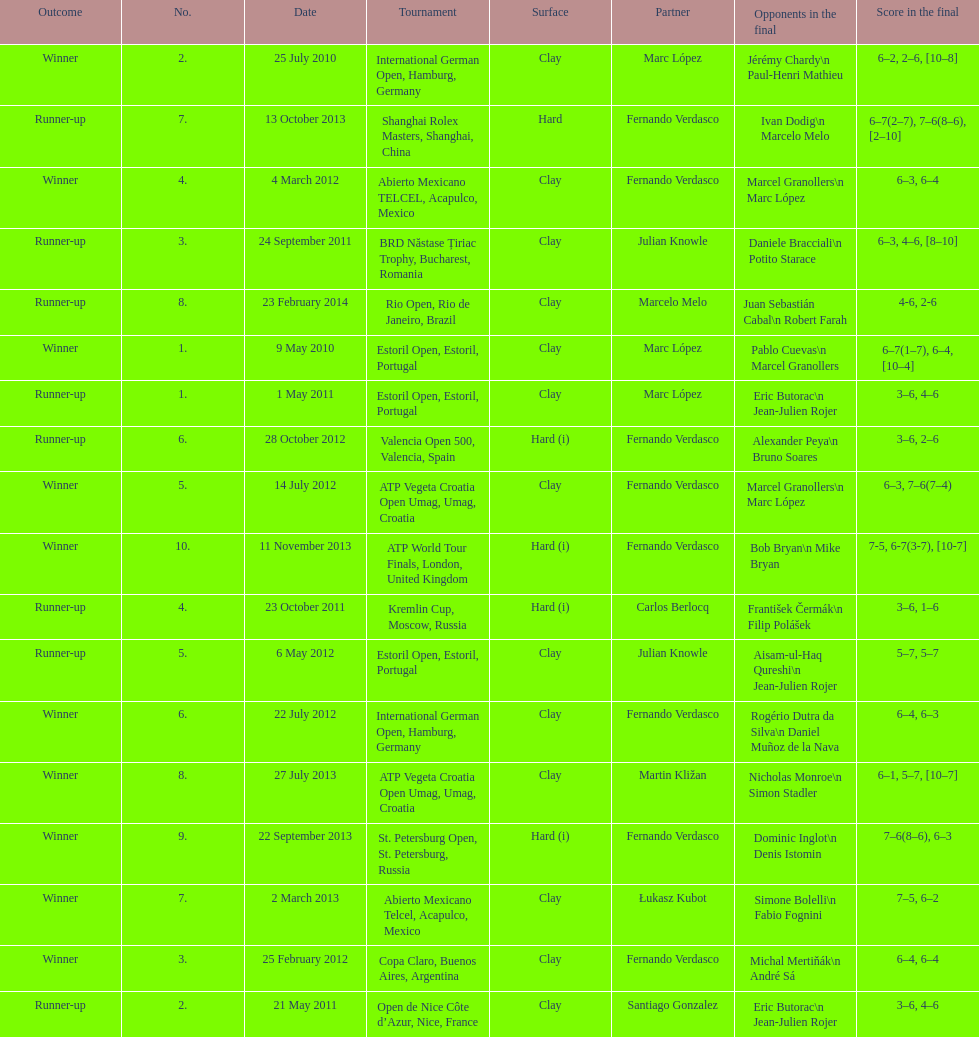What is the number of winning outcomes? 10. 